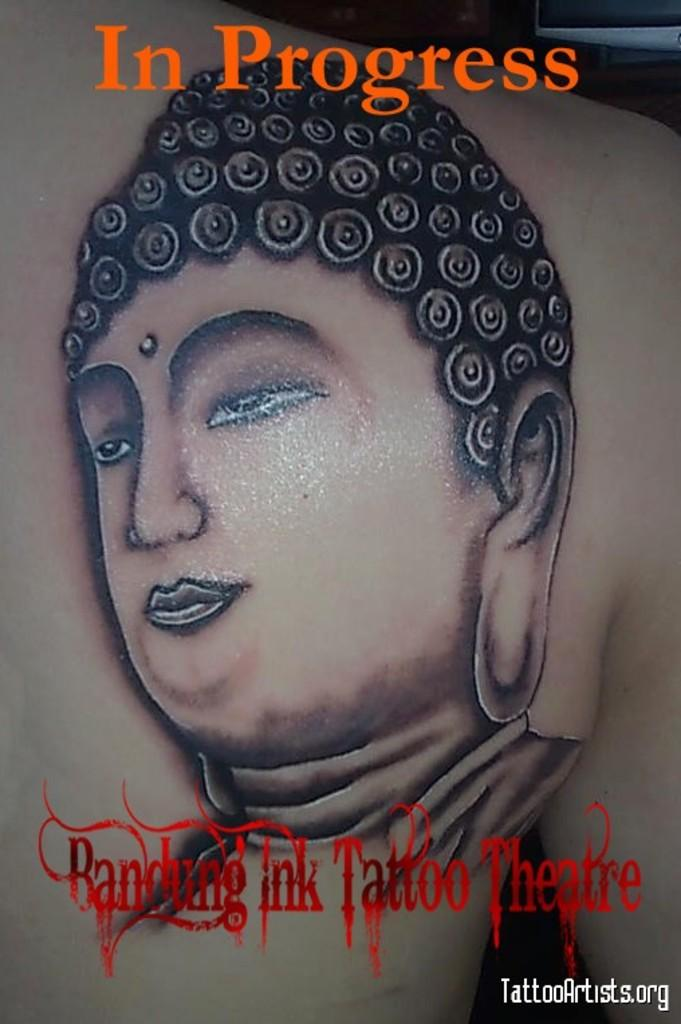What is the main subject of the image? There is a picture of Gautama Buddha in the image. What else can be seen in the image besides the picture of Gautama Buddha? There is text present in the image. What type of voice does the doll have in the image? There is no doll present in the image, so it is not possible to determine the type of voice it might have. 